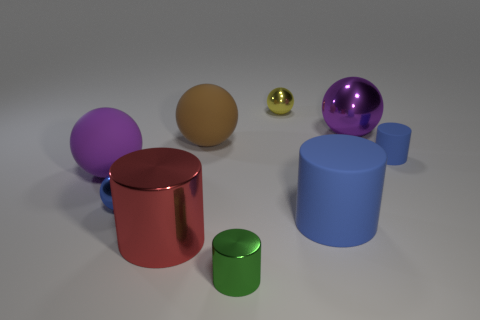Subtract all brown balls. How many balls are left? 4 Add 1 tiny gray matte objects. How many objects exist? 10 Subtract all gray spheres. How many blue cylinders are left? 2 Subtract all blue balls. How many balls are left? 4 Subtract all balls. How many objects are left? 4 Subtract 2 cylinders. How many cylinders are left? 2 Subtract 0 cyan cylinders. How many objects are left? 9 Subtract all cyan balls. Subtract all red cylinders. How many balls are left? 5 Subtract all big matte cylinders. Subtract all red shiny objects. How many objects are left? 7 Add 9 big brown objects. How many big brown objects are left? 10 